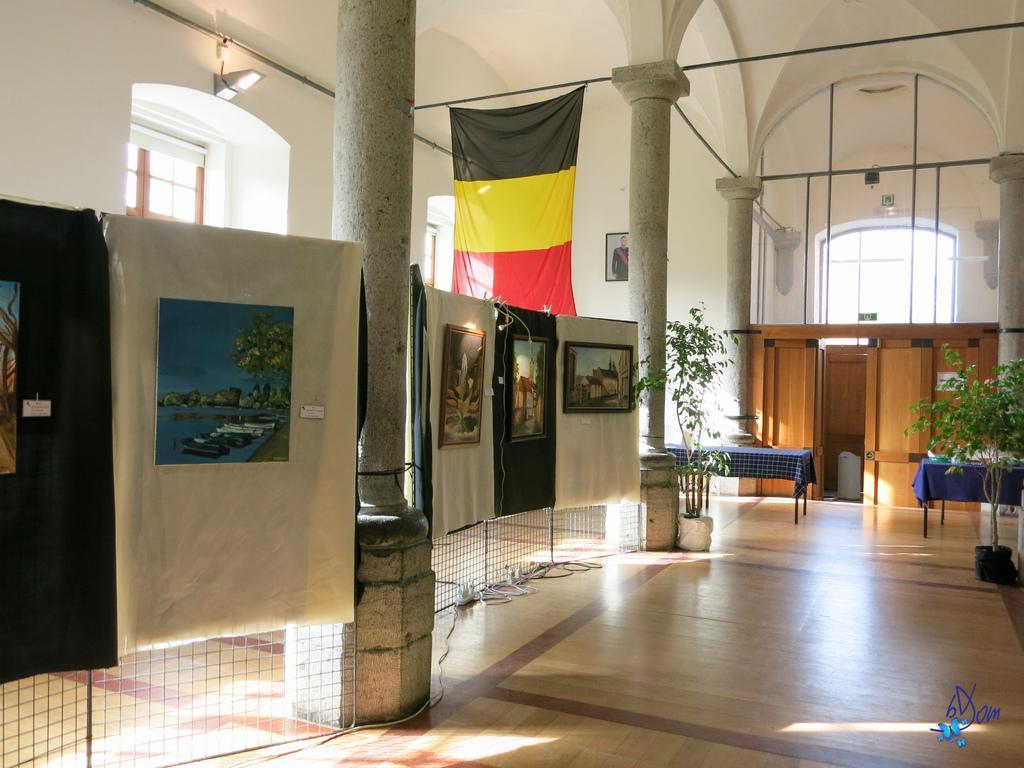Can you describe this image briefly? In this image, we can see grills, banners. Here we can see some paintings, walls, doors, plants, with pots, pillars, tables with cloth, windows, rods. At the bottom, there is a floor. Right side bottom, we can see a watermark. 